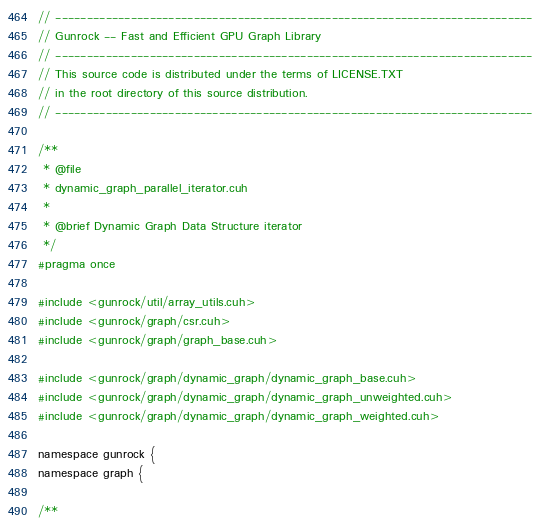<code> <loc_0><loc_0><loc_500><loc_500><_Cuda_>// ----------------------------------------------------------------------------
// Gunrock -- Fast and Efficient GPU Graph Library
// ----------------------------------------------------------------------------
// This source code is distributed under the terms of LICENSE.TXT
// in the root directory of this source distribution.
// ----------------------------------------------------------------------------

/**
 * @file
 * dynamic_graph_parallel_iterator.cuh
 *
 * @brief Dynamic Graph Data Structure iterator
 */
#pragma once

#include <gunrock/util/array_utils.cuh>
#include <gunrock/graph/csr.cuh>
#include <gunrock/graph/graph_base.cuh>

#include <gunrock/graph/dynamic_graph/dynamic_graph_base.cuh>
#include <gunrock/graph/dynamic_graph/dynamic_graph_unweighted.cuh>
#include <gunrock/graph/dynamic_graph/dynamic_graph_weighted.cuh>

namespace gunrock {
namespace graph {

/**</code> 